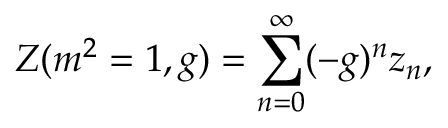Convert formula to latex. <formula><loc_0><loc_0><loc_500><loc_500>Z ( m ^ { 2 } = 1 , g ) = \sum _ { n = 0 } ^ { \infty } ( - g ) ^ { n } z _ { n } ,</formula> 